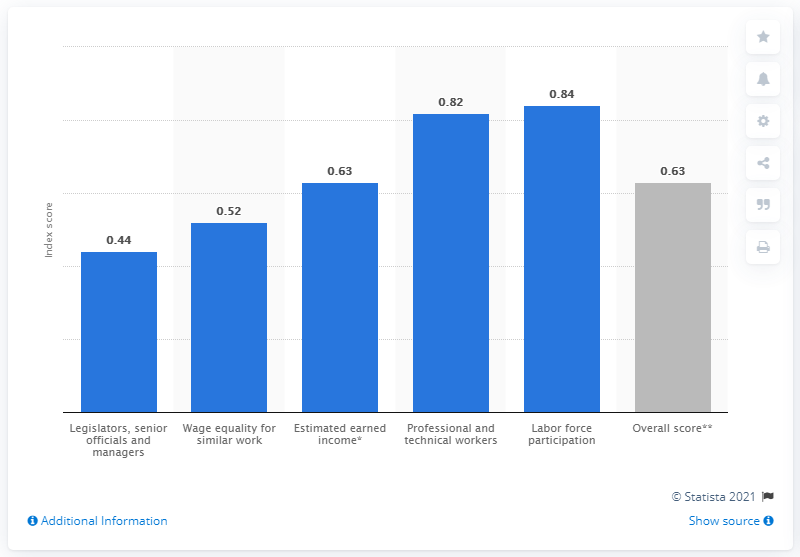What was Peru's gender gap index score in 2021?
 0.63 